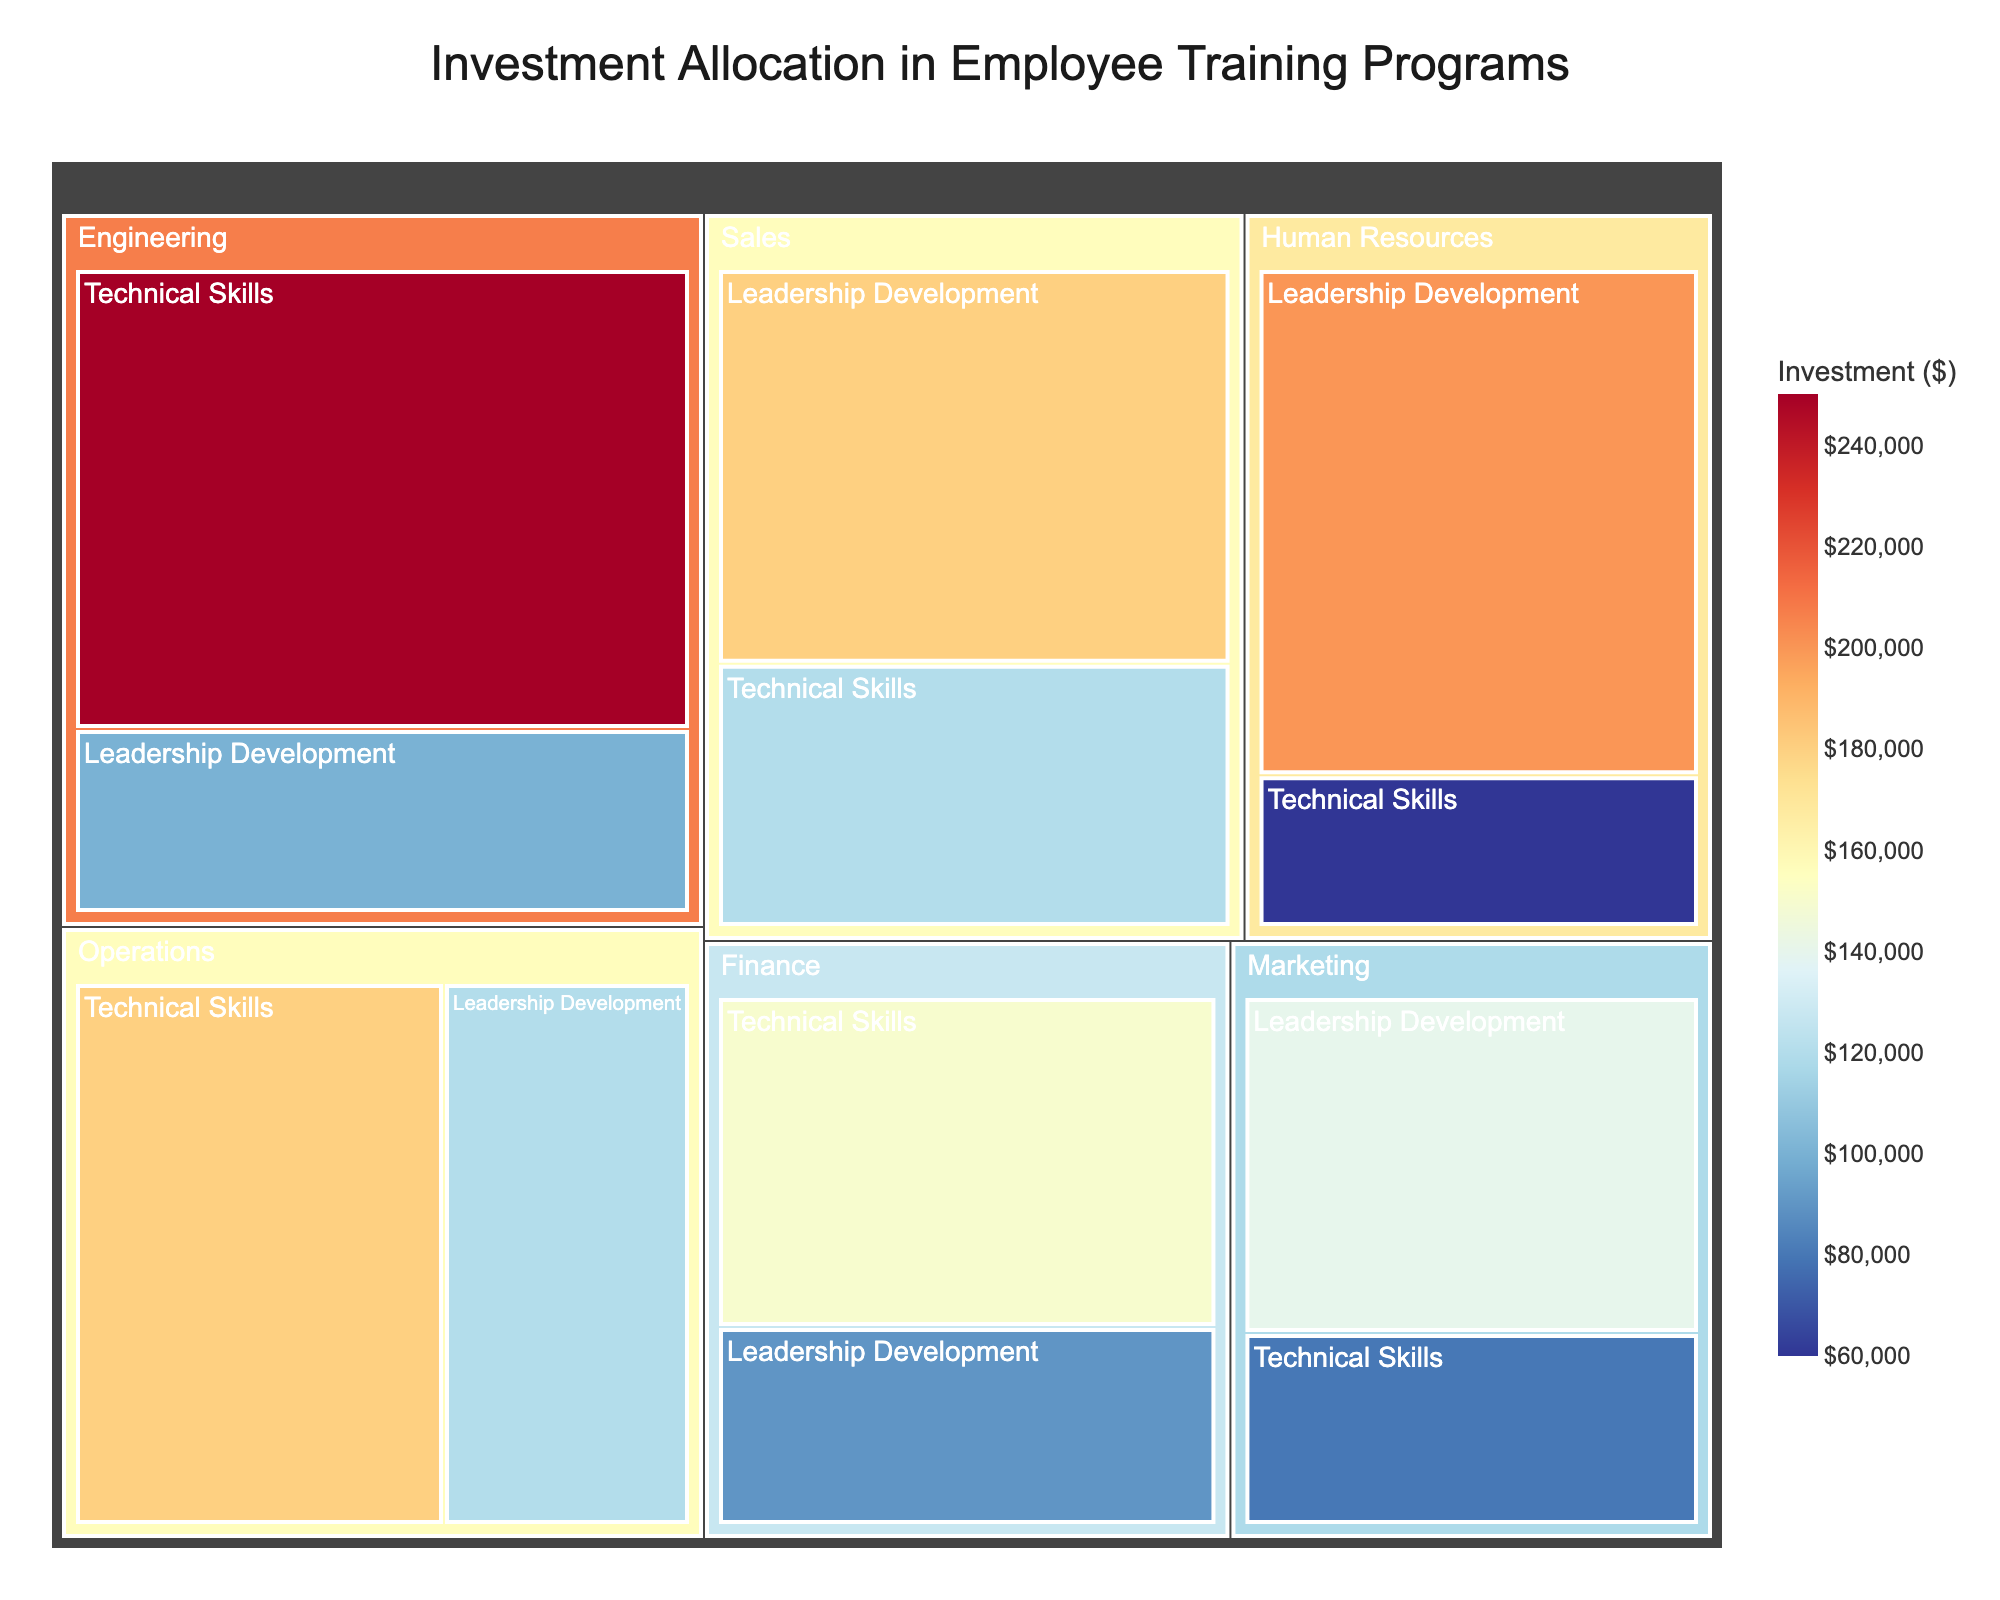What's the title of the Treemap? The title is clearly visible at the top of the Treemap.
Answer: Investment Allocation in Employee Training Programs Which department has the highest investment in Leadership Development programs? By examining the Treemap, you can see that Human Resources has the largest segment under Leadership Development.
Answer: Human Resources What is the total investment allocated to the Sales department? Add the investments in both Technical Skills and Leadership Development for the Sales department: $120,000 + $180,000.
Answer: $300,000 Compare the investment between Engineering and Operations in Technical Skills. Which one is higher? Look at the two segments under Technical Skills for both departments and compare their sizes: Engineering has $250,000, while Operations has $180,000.
Answer: Engineering How much more is invested in Leadership Development in Human Resources compared to Finance? Subtract the investment in Finance's Leadership Development from that in Human Resources: $200,000 - $90,000.
Answer: $110,000 Which category has the highest total investment across all departments? Sum the investments for each category: Leadership Development ($100,000 + $180,000 + $140,000 + $90,000 + $200,000 + $120,000 = $830,000) and Technical Skills ($250,000 + $120,000 + $80,000 + $150,000 + $60,000 + $180,000 = $840,000).
Answer: Technical Skills What's the combined investment in employee training programs for Marketing? Add the investments in both Technical Skills and Leadership Development for Marketing: $80,000 + $140,000.
Answer: $220,000 Which department has the smallest investment in any program category? Compare all segments' sizes and values; Human Resources in Technical Skills has the smallest investment at $60,000.
Answer: Human Resources (Technical Skills) What is the average investment per department in Technical Skills? Add all Technical Skills investments ($250,000 + $120,000 + $80,000 + $150,000 + $60,000 + $180,000 = $840,000) and divide by the number of departments (6).
Answer: $140,000 Is the investment in Leadership Development for Sales greater than the total investment in Technical Skills for Human Resources and Finance combined? Compare $180,000 in Leadership Development for Sales with the sum of Technical Skills investments in Human Resources and Finance: $60,000 + $150,000 = $210,000.
Answer: No 